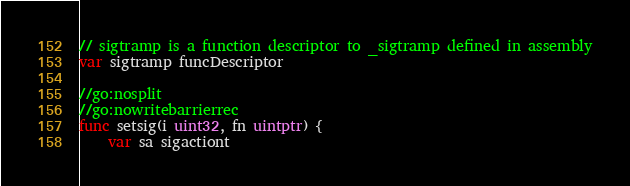Convert code to text. <code><loc_0><loc_0><loc_500><loc_500><_Go_>
// sigtramp is a function descriptor to _sigtramp defined in assembly
var sigtramp funcDescriptor

//go:nosplit
//go:nowritebarrierrec
func setsig(i uint32, fn uintptr) {
	var sa sigactiont</code> 